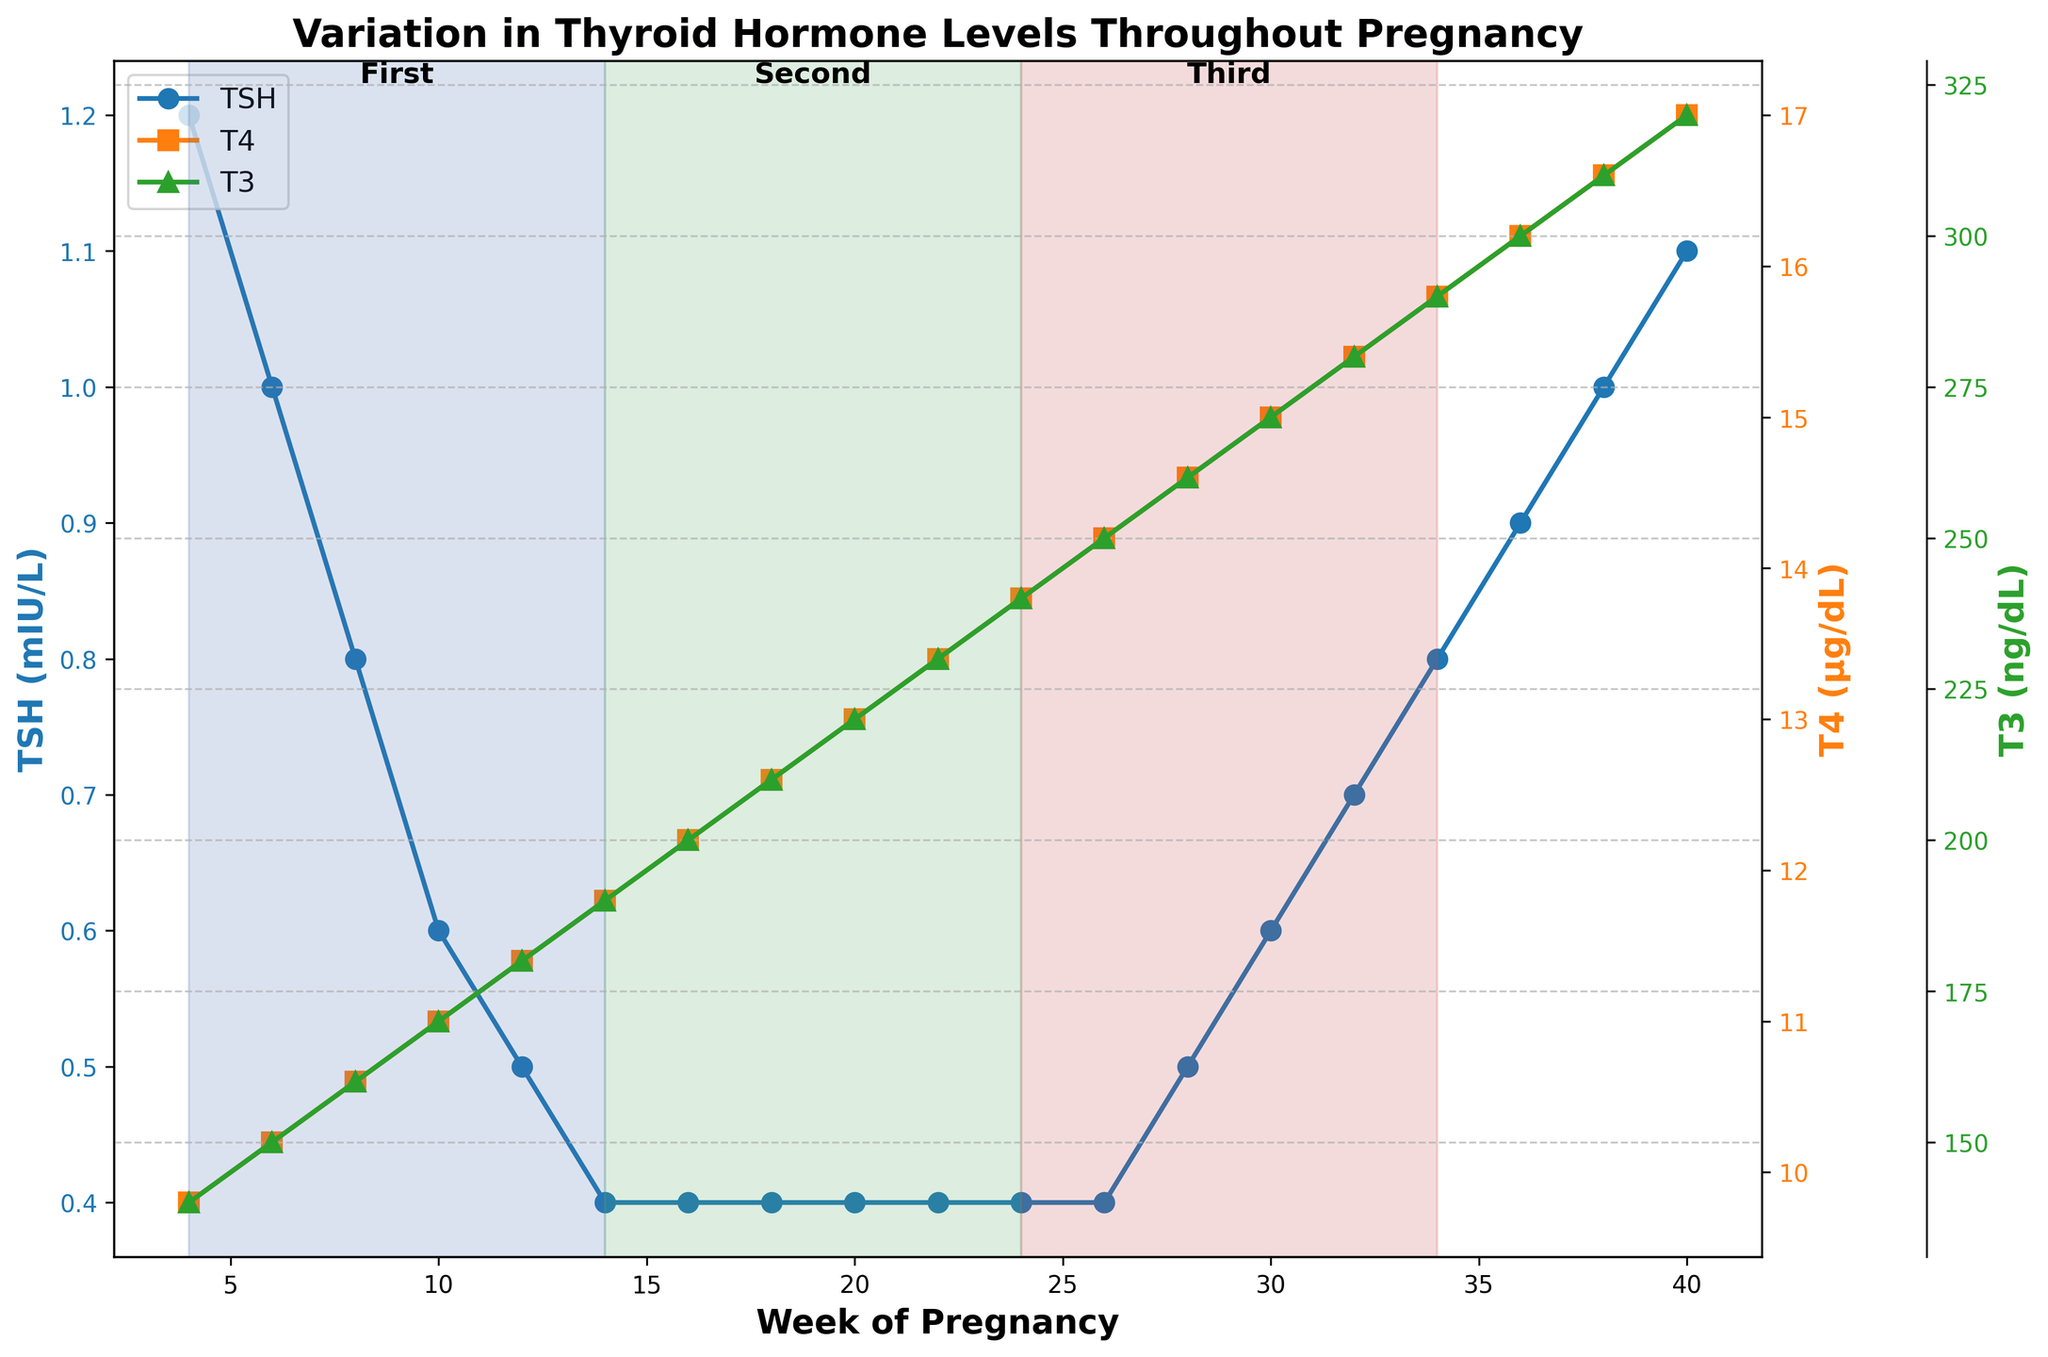What is the TSH level at the beginning of the first trimester? The beginning of the first trimester corresponds to week 4. By looking at the figure, you can see the TSH level at week 4.
Answer: 1.2 mIU/L How do the TSH levels change from the first trimester to the third trimester? To determine the change in TSH levels, compare the values at the start of the first trimester (week 4) and the end of the third trimester (week 40). From the figure, TSH decreases at the start of the pregnancy and then increases steadily till the third trimester.
Answer: Decreases initially, then increases How much does the T4 hormone level increase from week 4 to week 40? Identify the T4 levels at week 4 and week 40. At week 4, T4 is 9.8 μg/dL, and at week 40, it is 17.0 μg/dL. Calculate the difference: 17.0 - 9.8 = 7.2 μg/dL.
Answer: 7.2 μg/dL Which hormone shows a steady increase throughout pregnancy? Based on the figure, observe the trend lines for TSH, T4, and T3 hormones. Both T4 and T3 show a steady increase throughout the pregnancy period.
Answer: T4 and T3 What is the relationship between TSH levels and T3 levels during the second trimester? During the second trimester, examine how TSH and T3 levels change. While TSH remains relatively constant at 0.4 mIU/L, T3 levels gradually increase from 190 ng/dL to 250 ng/dL.
Answer: TSH levels remain constant, T3 levels increase At which week do both T4 and T3 hormones reach the same rate of increase? Analyze the slope of the T4 and T3 hormone lines in the figure. The rate of increase of both hormones appears similar during the second trimester, starting around week 14.
Answer: Around week 14 Does the TSH level return to its initial value at the end of pregnancy? Compare the TSH level at the beginning (week 4, 1.2 mIU/L) and the end of pregnancy (week 40, 1.1 mIU/L). Both values are very close, showing it almost returns to the initial level.
Answer: Almost returns Between which weeks does the T4 hormone show the most significant increase? Calculate the difference in the T4 levels between consecutive weeks and find the period with the largest increase. The most significant increase in T4 occurs from week 26 to week 40.
Answer: Week 26 to week 40 What is the TSH level around week 24? From the figure, find the TSH level corresponding to week 24. It shows a consistent low level of TSH during the second trimester.
Answer: 0.4 mIU/L How do the T4 levels differ between weeks 16 and 28? Identify the T4 levels at weeks 16 and 28. At week 16, T4 is 12.2 μg/dL, and at week 28, it is 14.6 μg/dL. Calculate the difference: 14.6 - 12.2 = 2.4 μg/dL.
Answer: 2.4 μg/dL 